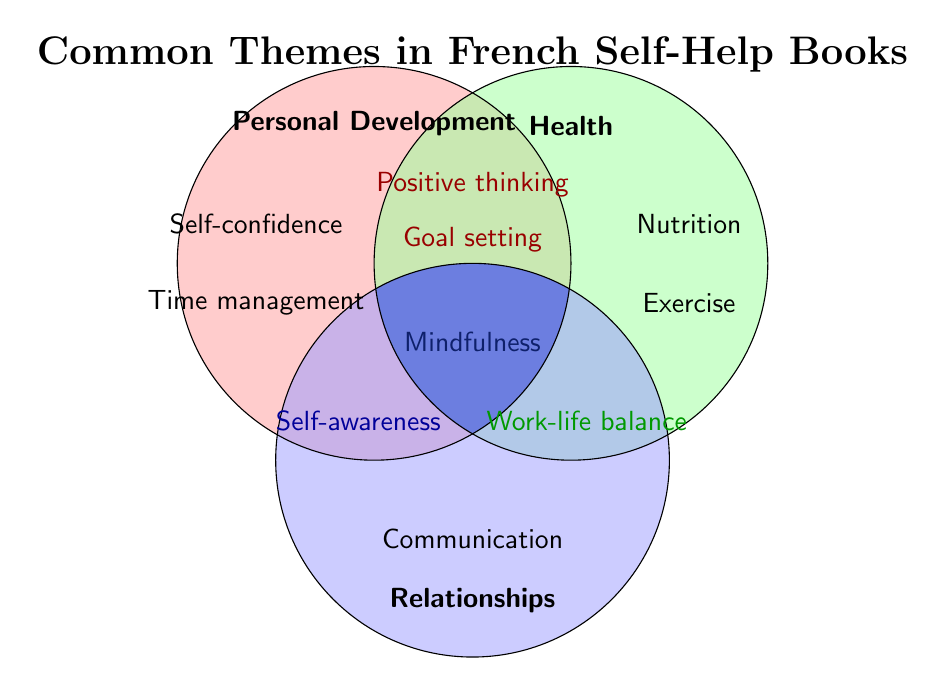What are the three main categories in the Venn Diagram? The Venn Diagram contains three main categories which are identified by their respective colors and labels at the top of the circles. They are Personal Development (red), Health (green), and Relationships (blue).
Answer: Personal Development, Health, and Relationships Which category contains "Self-confidence"? The text "Self-confidence" is located entirely within the red circle, which corresponds to the category Personal Development.
Answer: Personal Development Where is "Mindfulness" located in the Venn Diagram? "Mindfulness" is positioned in the center where all three circles overlap. This indicates that it is a theme common to Personal Development, Health, and Relationships.
Answer: Center overlap of all three circles How many themes are present in the intersection of Personal Development and Health? The intersection of the red and green circles shows two themes: Positive thinking and Goal setting.
Answer: 2 themes What theme appears in the intersection of Health and Relationships but not in Personal Development? The intersection of the green and blue circles (Health and Relationships) but not in red (Personal Development) contains the theme Work-life balance.
Answer: Work-life balance Which category uniquely includes "Nutrition"? The theme "Nutrition" is located entirely within the green circle, indicating it belongs solely to the Health category.
Answer: Health Identify a theme that is common to both Personal Development and Relationships but not Health. In the intersection of the red (Personal Development) and blue (Relationships) circles, but not overlapping with the green (Health) circle, the theme Self-awareness is found.
Answer: Self-awareness What theme appears uniquely in Relationships but not in the other categories? The theme "Communication" is positioned entirely within the blue circle, indicating that it is unique to the Relationships category.
Answer: Communication Name a theme common to Personal Development and Health. Both the red (Personal Development) and green (Health) circles overlap in two places, indicating the themes Positive thinking and Goal setting.
Answer: Positive thinking and Goal setting 